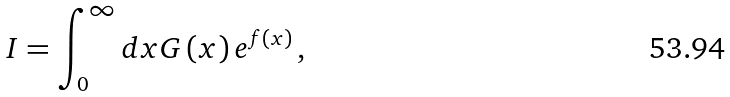Convert formula to latex. <formula><loc_0><loc_0><loc_500><loc_500>I = \int _ { 0 } ^ { \infty } d x G \left ( x \right ) e ^ { f \left ( x \right ) } \, ,</formula> 